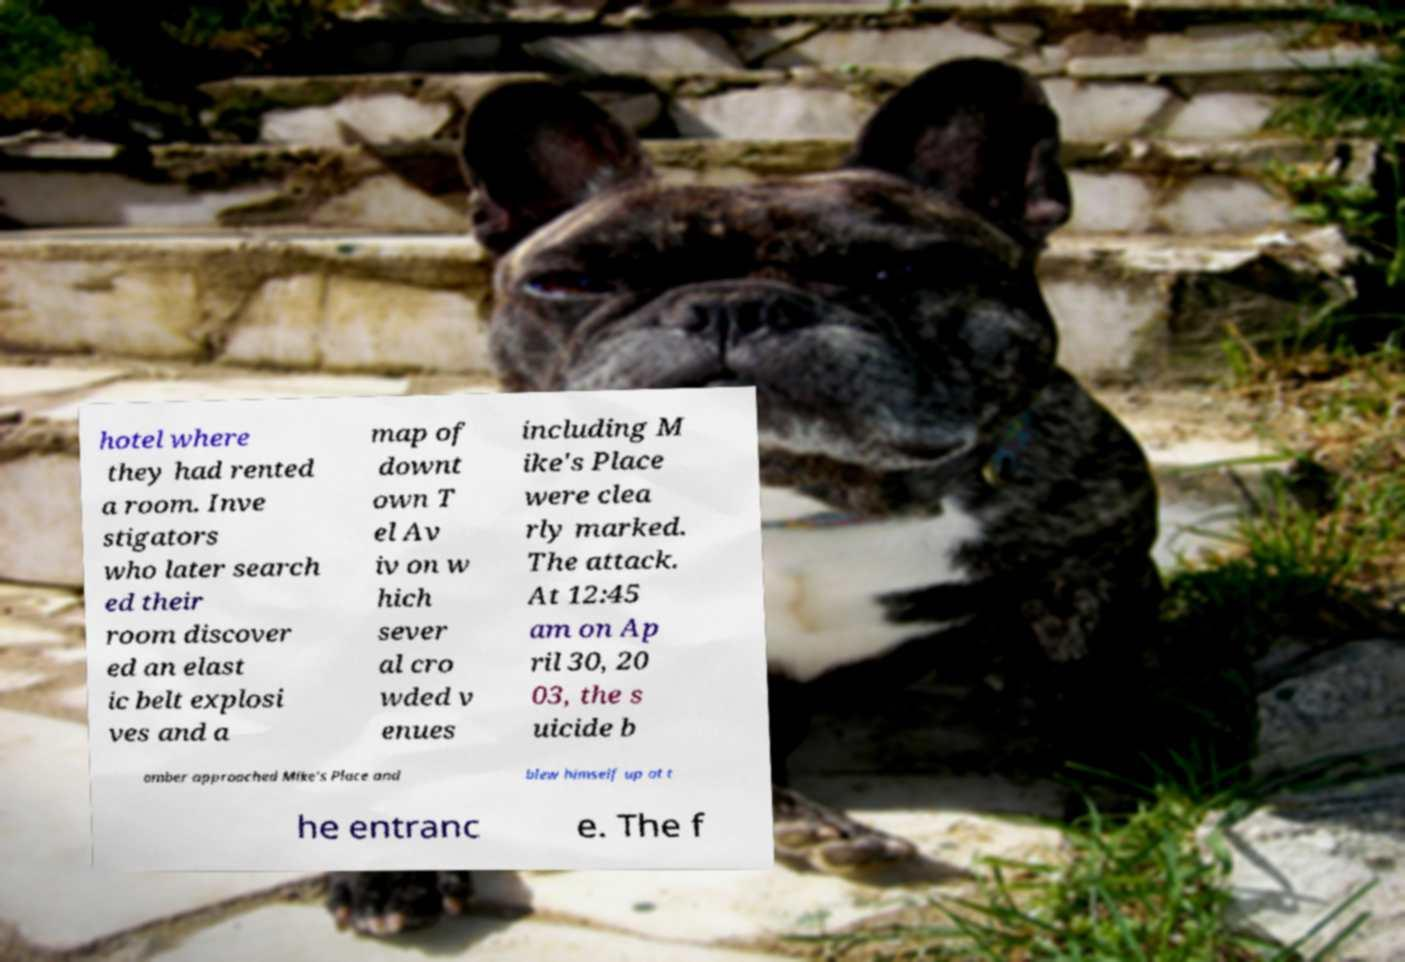For documentation purposes, I need the text within this image transcribed. Could you provide that? hotel where they had rented a room. Inve stigators who later search ed their room discover ed an elast ic belt explosi ves and a map of downt own T el Av iv on w hich sever al cro wded v enues including M ike's Place were clea rly marked. The attack. At 12:45 am on Ap ril 30, 20 03, the s uicide b omber approached Mike's Place and blew himself up at t he entranc e. The f 